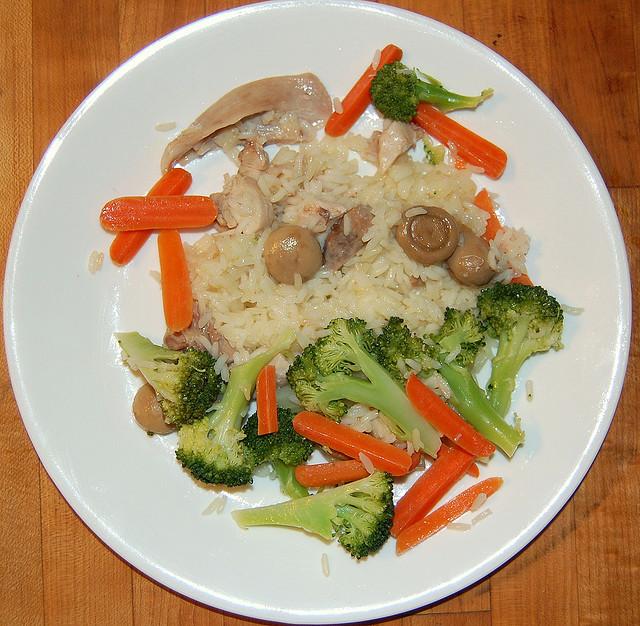Is there any rice?
Quick response, please. Yes. What shape are the mushroom caps?
Answer briefly. Round. What color is the plate?
Be succinct. White. What two vegetables are present?
Write a very short answer. Broccoli and carrots. 